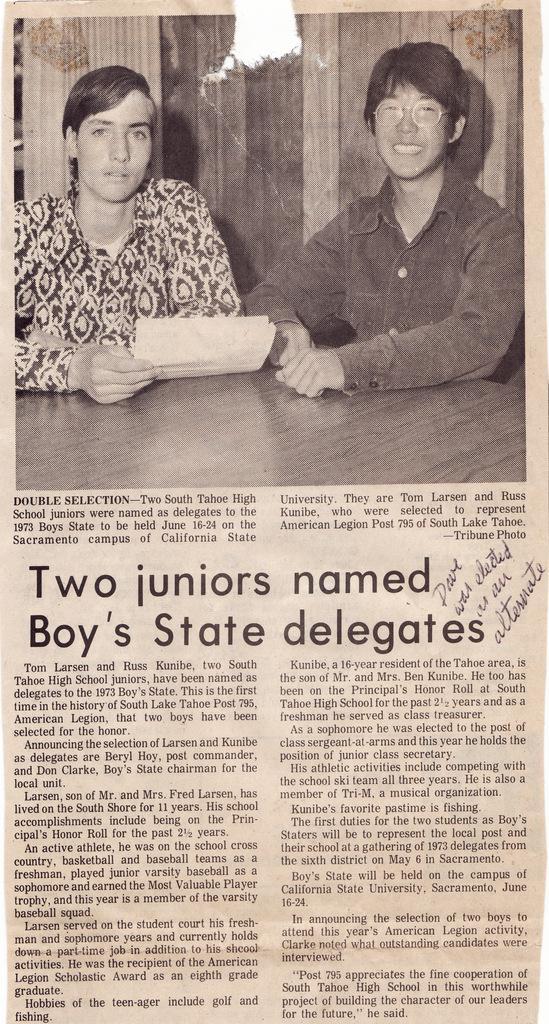Please provide a concise description of this image. This is a paper. At the top of the image we can see the wall, table and two people are sitting and smiling and a person is holding a paper. At the bottom of the image we can see the text. 